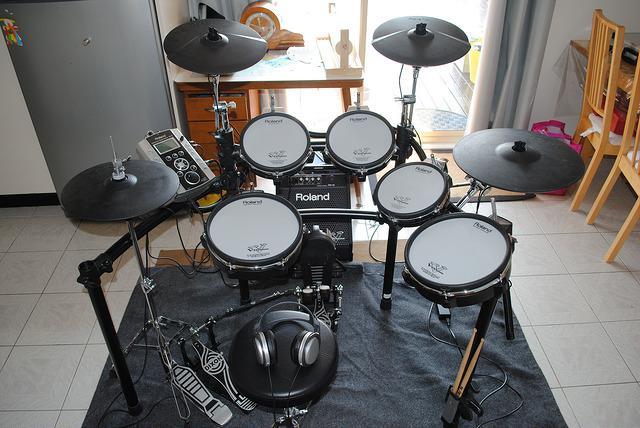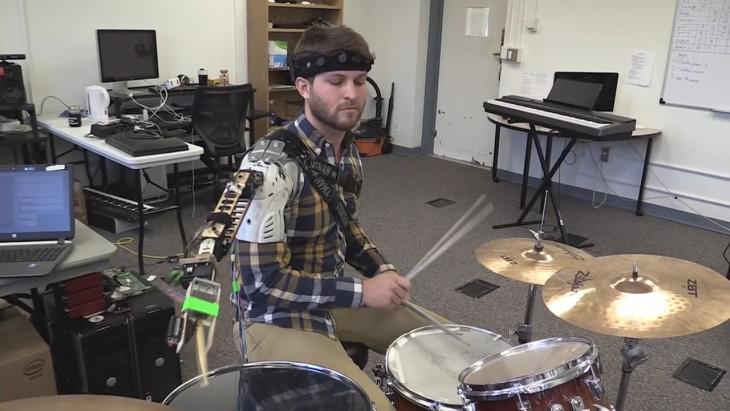The first image is the image on the left, the second image is the image on the right. For the images displayed, is the sentence "The image on the right shows a single person playing a drum kit with drumsticks." factually correct? Answer yes or no. Yes. The first image is the image on the left, the second image is the image on the right. Examine the images to the left and right. Is the description "An image includes at least one person wearing a type of harness and standing behind a set of connected drums with four larger drums in front of two smaller ones." accurate? Answer yes or no. No. 